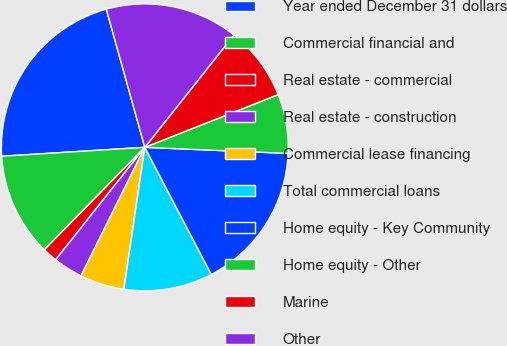Convert chart to OTSL. <chart><loc_0><loc_0><loc_500><loc_500><pie_chart><fcel>Year ended December 31 dollars<fcel>Commercial financial and<fcel>Real estate - commercial<fcel>Real estate - construction<fcel>Commercial lease financing<fcel>Total commercial loans<fcel>Home equity - Key Community<fcel>Home equity - Other<fcel>Marine<fcel>Other<nl><fcel>21.66%<fcel>11.67%<fcel>1.67%<fcel>3.34%<fcel>5.0%<fcel>10.0%<fcel>16.66%<fcel>6.67%<fcel>8.33%<fcel>15.0%<nl></chart> 